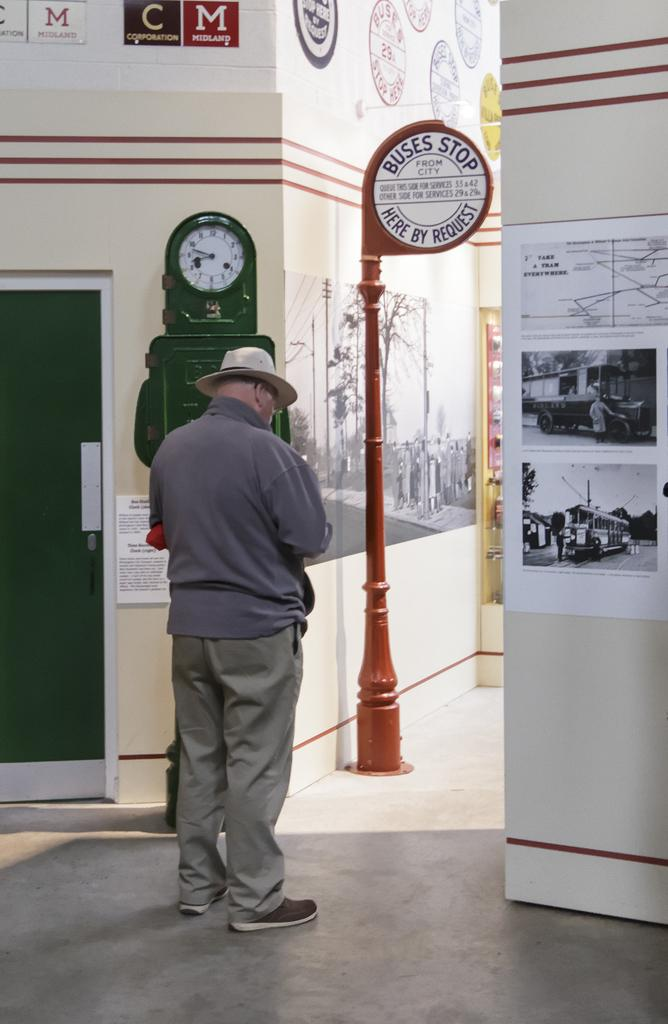<image>
Describe the image concisely. An older man is standing in a building with a clock and an antique bus stop sign by the door. 